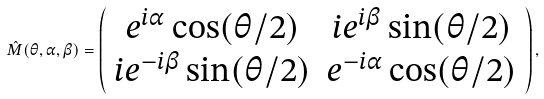Convert formula to latex. <formula><loc_0><loc_0><loc_500><loc_500>\hat { M } ( \theta , \alpha , \beta ) = \left ( \begin{array} { c c } e ^ { i \alpha } \cos ( \theta / 2 ) & i e ^ { i \beta } \sin ( \theta / 2 ) \\ i e ^ { - i \beta } \sin ( \theta / 2 ) & e ^ { - i \alpha } \cos ( \theta / 2 ) \end{array} \right ) ,</formula> 